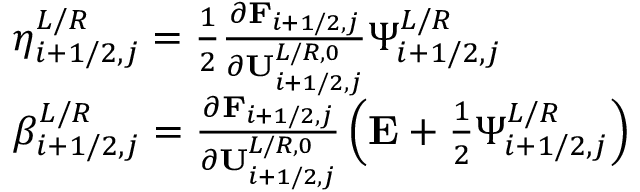<formula> <loc_0><loc_0><loc_500><loc_500>\begin{array} { r l } & { \eta _ { i + 1 / 2 , j } ^ { L / R } = \frac { 1 } { 2 } \frac { \partial F _ { i + 1 / 2 , j } } { \partial U _ { i + 1 / 2 , j } ^ { L / R , 0 } } \Psi _ { i + 1 / 2 , j } ^ { L / R } } \\ & { \beta _ { i + 1 / 2 , j } ^ { L / R } = \frac { \partial F _ { i + 1 / 2 , j } } { \partial U _ { i + 1 / 2 , j } ^ { L / R , 0 } } \left ( E + \frac { 1 } { 2 } \Psi _ { i + 1 / 2 , j } ^ { L / R } \right ) } \end{array}</formula> 